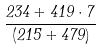<formula> <loc_0><loc_0><loc_500><loc_500>\frac { 2 3 4 + 4 1 9 \cdot 7 } { ( 2 1 5 + 4 7 9 ) }</formula> 